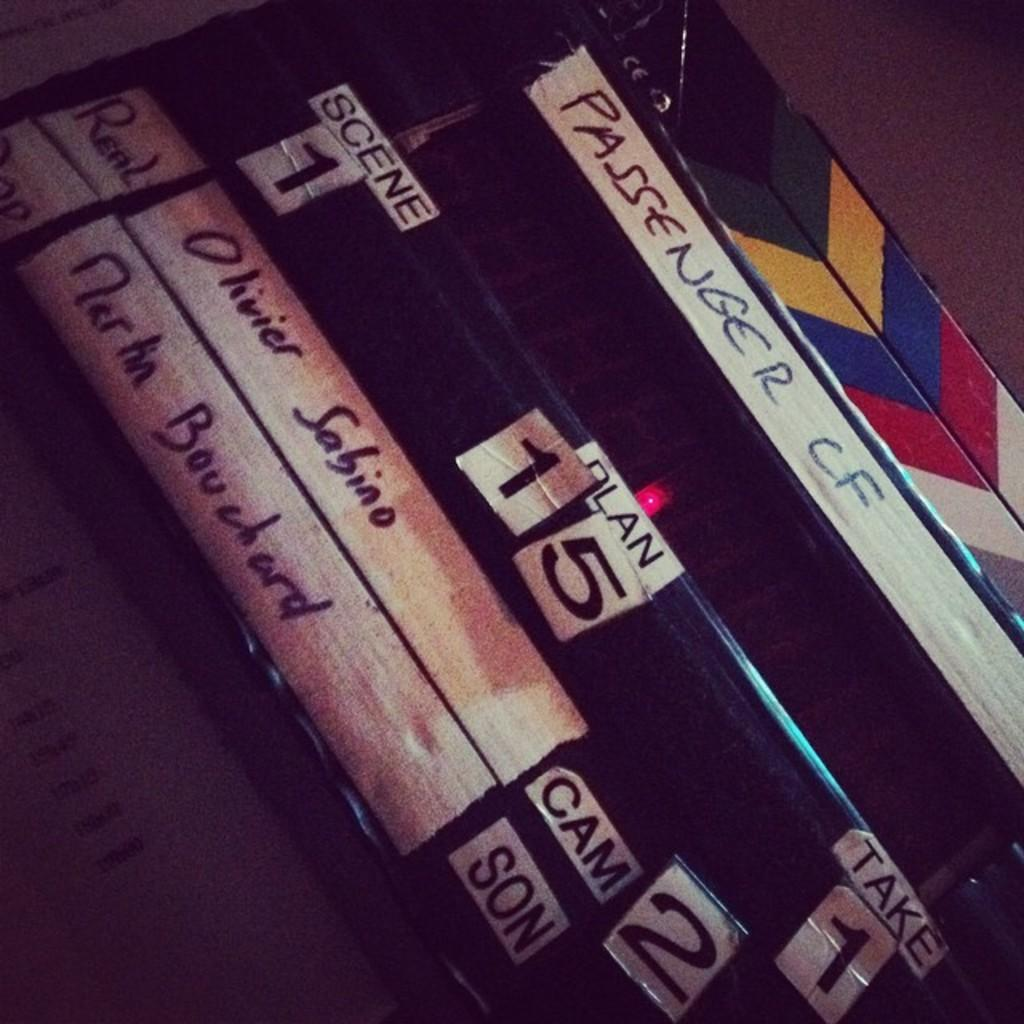<image>
Present a compact description of the photo's key features. Items relating to filmmaking are labelled by scene and other information. 